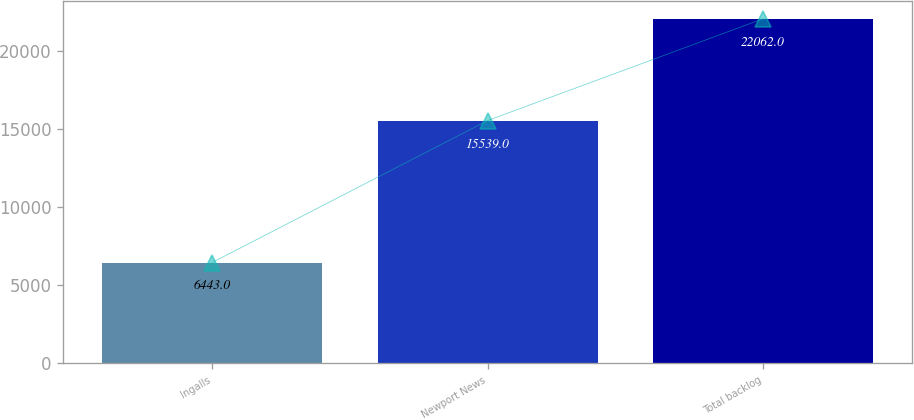<chart> <loc_0><loc_0><loc_500><loc_500><bar_chart><fcel>Ingalls<fcel>Newport News<fcel>Total backlog<nl><fcel>6443<fcel>15539<fcel>22062<nl></chart> 